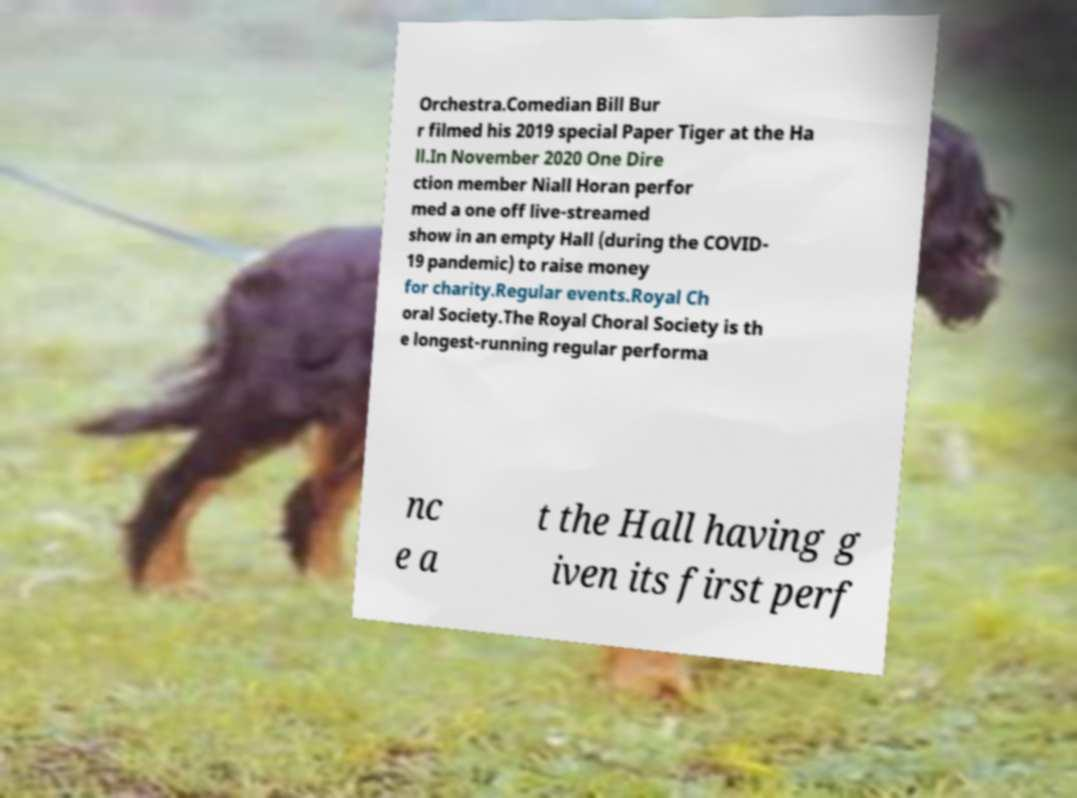Please identify and transcribe the text found in this image. Orchestra.Comedian Bill Bur r filmed his 2019 special Paper Tiger at the Ha ll.In November 2020 One Dire ction member Niall Horan perfor med a one off live-streamed show in an empty Hall (during the COVID- 19 pandemic) to raise money for charity.Regular events.Royal Ch oral Society.The Royal Choral Society is th e longest-running regular performa nc e a t the Hall having g iven its first perf 